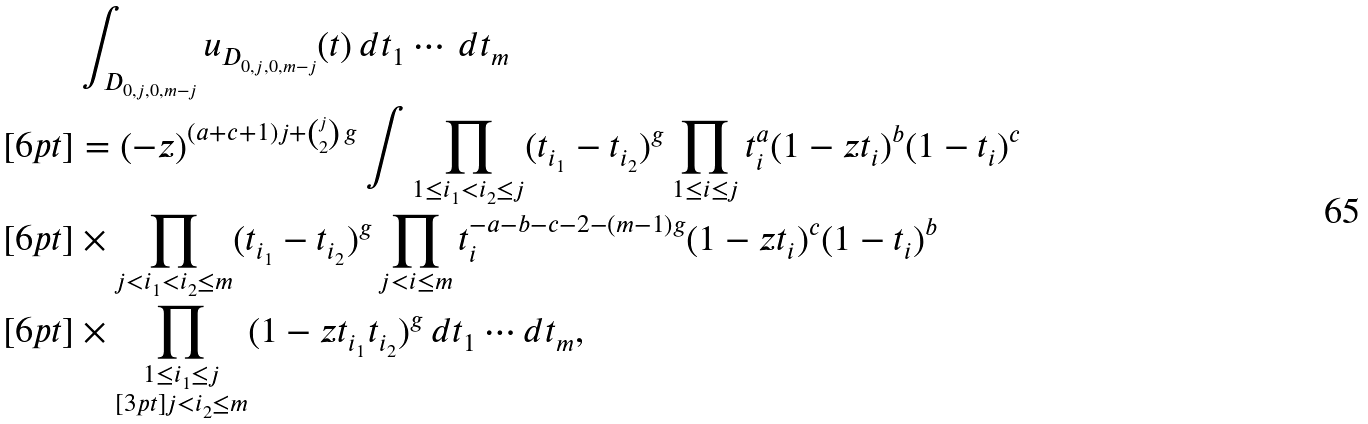Convert formula to latex. <formula><loc_0><loc_0><loc_500><loc_500>& \int _ { D _ { 0 , j , 0 , m - j } } u _ { D _ { 0 , j , 0 , m - j } } ( t ) \, d t _ { 1 } \cdots \, d t _ { m } \\ [ 6 p t ] & = ( - z ) ^ { ( a + c + 1 ) j + { j \choose 2 } \, g } \int \prod _ { 1 \leq i _ { 1 } < i _ { 2 } \leq j } ( t _ { i _ { 1 } } - t _ { i _ { 2 } } ) ^ { g } \prod _ { 1 \leq i \leq j } t _ { i } ^ { a } ( 1 - z t _ { i } ) ^ { b } ( 1 - t _ { i } ) ^ { c } \\ [ 6 p t ] & \times \prod _ { j < i _ { 1 } < i _ { 2 } \leq m } ( t _ { i _ { 1 } } - t _ { i _ { 2 } } ) ^ { g } \prod _ { j < i \leq m } t _ { i } ^ { - a - b - c - 2 - ( m - 1 ) g } ( 1 - z t _ { i } ) ^ { c } ( 1 - t _ { i } ) ^ { b } \, \\ [ 6 p t ] & \times \prod _ { \substack { 1 \leq i _ { 1 } \leq j \\ [ 3 p t ] j < i _ { 2 } \leq m } } ( 1 - z t _ { i _ { 1 } } t _ { i _ { 2 } } ) ^ { g } \, d t _ { 1 } \cdots d t _ { m } ,</formula> 